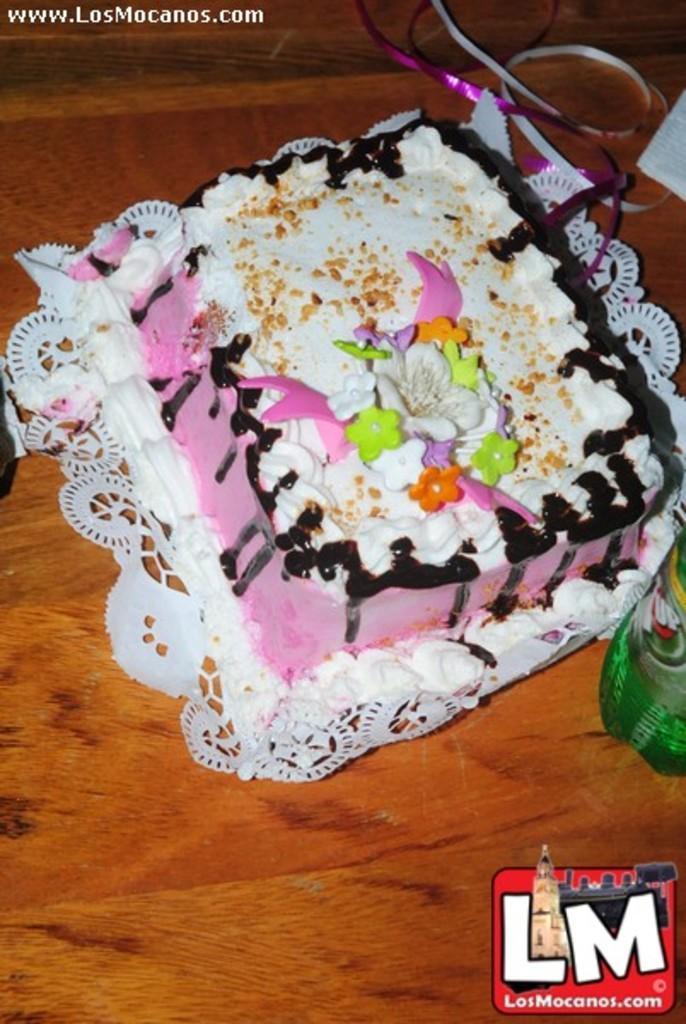In one or two sentences, can you explain what this image depicts? In this image there is a cake with full of cream , chocolate cream placed in a table and in table there are ribbons, tissue, bottle. 